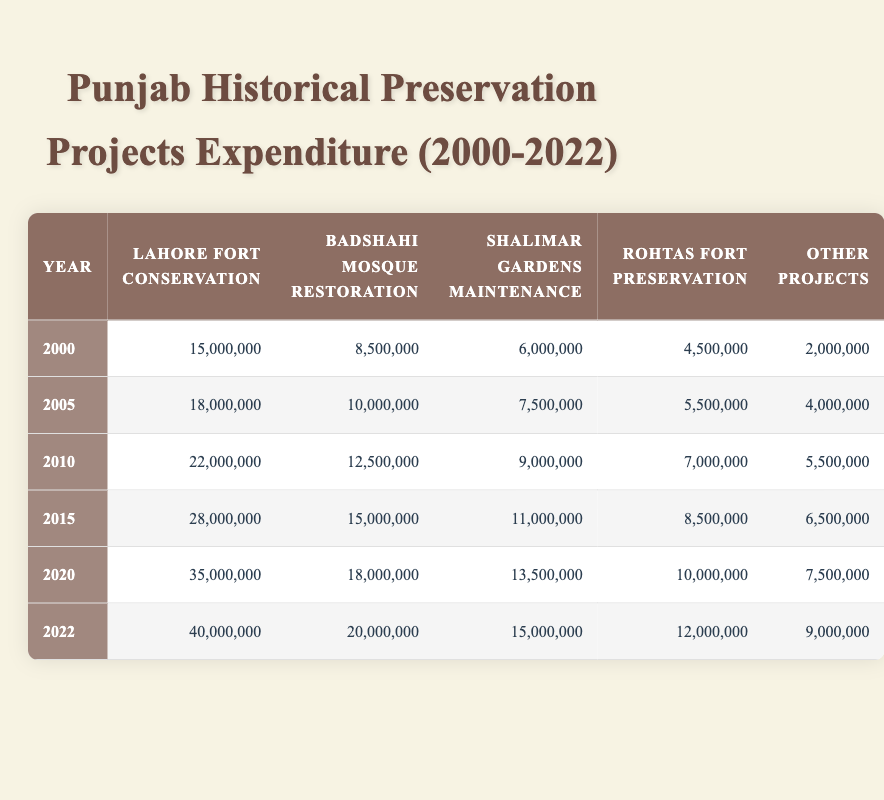What was the expenditure for Lahore Fort Conservation in 2010? The table shows that the expenditure for Lahore Fort Conservation in 2010 is listed under that year, which is 22,000,000.
Answer: 22,000,000 How much was spent on Badshahi Mosque Restoration in 2022? Referring to the table for the year 2022, the expenditure for Badshahi Mosque Restoration is recorded as 20,000,000.
Answer: 20,000,000 What is the total expenditure on historical projects in 2015? To find the total for 2015, add the individual expenditures: 28,000,000 (Lahore Fort Conservation) + 15,000,000 (Badshahi Mosque Restoration) + 11,000,000 (Shalimar Gardens Maintenance) + 8,500,000 (Rohtas Fort Preservation) + 6,500,000 (Other Projects) = 69,000,000.
Answer: 69,000,000 Has the expenditure for Rohtas Fort Preservation increased from 2000 to 2022? The expenditure in 2000 is 4,500,000, while in 2022 it is 12,000,000. Since 12,000,000 is greater than 4,500,000, it shows an increase.
Answer: Yes What was the average expenditure on Shalimar Gardens Maintenance from 2000 to 2022? The expenditures listed for Shalimar Gardens Maintenance are: 6,000,000 in 2000, 7,500,000 in 2005, 9,000,000 in 2010, 11,000,000 in 2015, 13,500,000 in 2020, and 15,000,000 in 2022. Adding these gives a total of 62,000,000, and there are 6 years, so the average is 62,000,000 / 6 = 10,333,333.
Answer: 10,333,333 What was the highest expenditure for "Other Projects" and in which year? From the table, the values for "Other Projects" are: 2,000,000 (2000), 4,000,000 (2005), 5,500,000 (2010), 6,500,000 (2015), 7,500,000 (2020), and 9,000,000 (2022). The highest value is 9,000,000 in 2022.
Answer: 9,000,000 in 2022 What percentage increase was there in expenditure for Lahore Fort Conservation from 2000 to 2022? The expenditure for Lahore Fort Conservation in 2000 was 15,000,000 and in 2022 it was 40,000,000. To find the percentage increase: ((40,000,000 - 15,000,000) / 15,000,000) * 100 = (25,000,000 / 15,000,000) * 100 = 166.67%.
Answer: 166.67% Is the total expenditure on historical preservation projects in 2020 higher than the total in 2010? The total for 2020 is 35,000,000 (Lahore Fort) + 18,000,000 (Badshahi Mosque) + 13,500,000 (Shalimar Gardens) + 10,000,000 (Rohtas Fort) + 7,500,000 (Other Projects) = 84,000,000. The total for 2010 is 22,000,000 (Lahore Fort) + 12,500,000 (Badshahi Mosque) + 9,000,000 (Shalimar Gardens) + 7,000,000 (Rohtas Fort) + 5,500,000 (Other Projects) = 56,000,000. Since 84,000,000 > 56,000,000, 2020 is higher.
Answer: Yes 